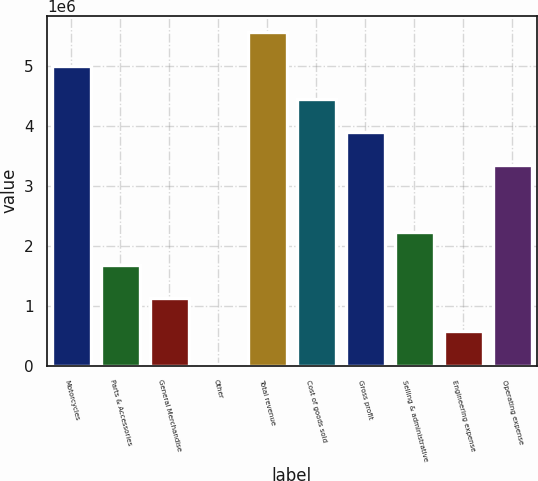Convert chart. <chart><loc_0><loc_0><loc_500><loc_500><bar_chart><fcel>Motorcycles<fcel>Parts & Accessories<fcel>General Merchandise<fcel>Other<fcel>Total revenue<fcel>Cost of goods sold<fcel>Gross profit<fcel>Selling & administrative<fcel>Engineering expense<fcel>Operating expense<nl><fcel>5.01311e+06<fcel>1.68569e+06<fcel>1.13111e+06<fcel>21973<fcel>5.56768e+06<fcel>4.45854e+06<fcel>3.90397e+06<fcel>2.24026e+06<fcel>576544<fcel>3.3494e+06<nl></chart> 